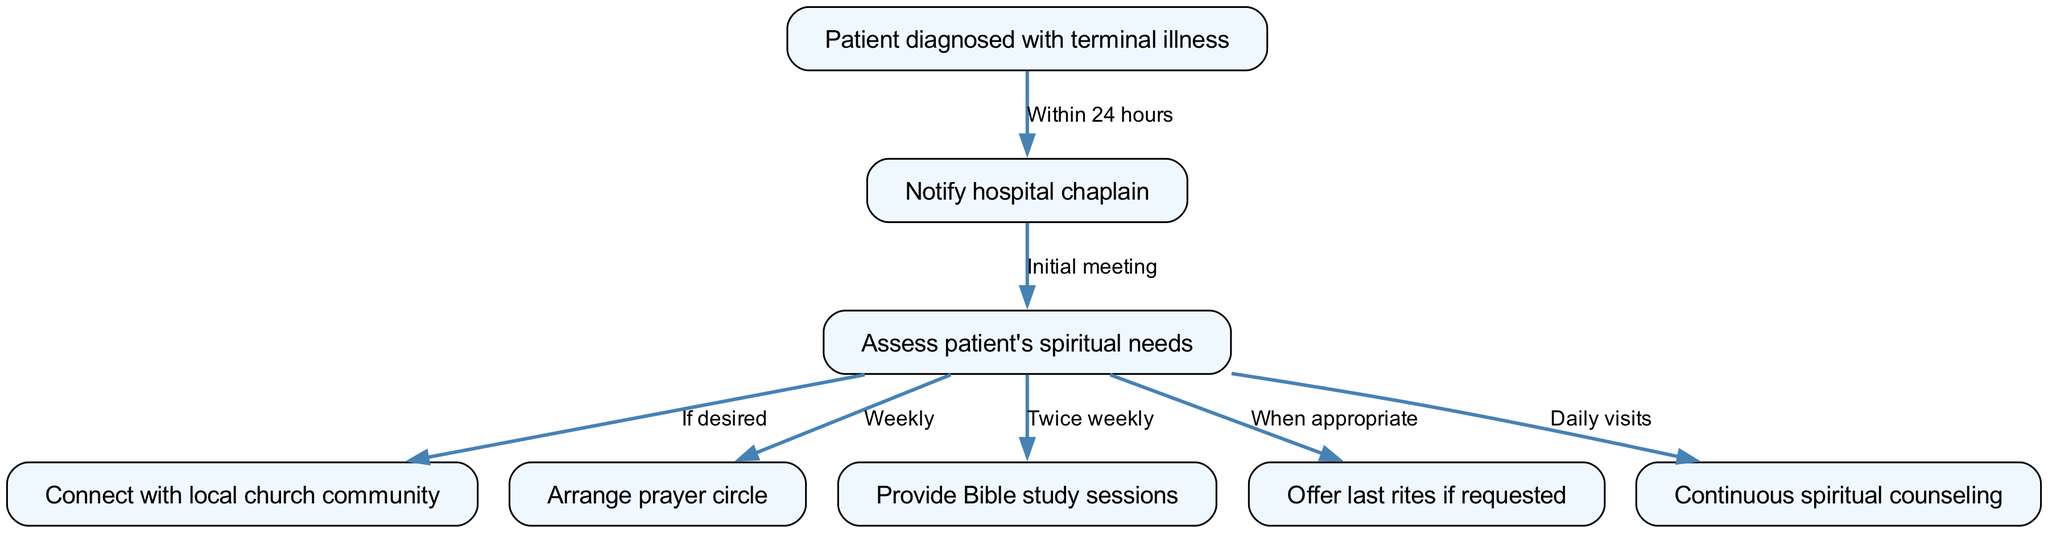What is the first step for a patient diagnosed with terminal illness? The first step as per the diagram is for the hospital to notify the chaplain within 24 hours of the patient's diagnosis. This is indicated by the edge connecting node 1 to node 2.
Answer: Notify hospital chaplain How many nodes are there in the diagram? The diagram contains a total of 8 nodes, which represent different steps and services provided for the patient diagnosed with a terminal illness. This total can be counted directly from the nodes listed.
Answer: 8 What service is provided weekly according to the pathway? The service provided weekly is the arrangement of a prayer circle, which is shown as a connection from the assessment of the patient's spiritual needs.
Answer: Arrange prayer circle Which node is connected to the "Assess patient's spiritual needs" node? Multiple nodes are connected to the "Assess patient's spiritual needs" node, including the local church community, prayer circle, Bible study sessions, last rites, and continuous spiritual counseling. This shows different pathways and services based on the patient’s desires.
Answer: Connect with local church community, Arrange prayer circle, Provide Bible study sessions, Offer last rites if requested, Continuous spiritual counseling How frequently are Bible study sessions provided? According to the diagram, Bible study sessions are offered twice weekly as indicated by the edge flowing from the patient's spiritual needs assessment to the Bible study sessions node.
Answer: Twice weekly What happens when a patient requests last rites? The diagram specifies that last rites are offered when appropriate, showcasing the chaplain's adaptability to the patient’s spiritual needs as assessed. This relationship indicates a conditional service based on patient request.
Answer: Offer last rites if requested What type of counseling is provided daily? Daily visits for continuous spiritual counseling are provided, according to the pathway, which underscores the importance of support throughout the patient’s care journey.
Answer: Continuous spiritual counseling Which services follow the initial meeting with the chaplain? Following the initial meeting with the chaplain, the services that may follow include assessing the patient's spiritual needs and possibly connecting with the local church community, arranging prayer circles, providing Bible study sessions, and offering last rites when appropriate. This indicates the comprehensive nature of support after the initial assessment.
Answer: Assess patient's spiritual needs, Connect with local church community, Arrange prayer circle, Provide Bible study sessions, Offer last rites if requested, Continuous spiritual counseling 